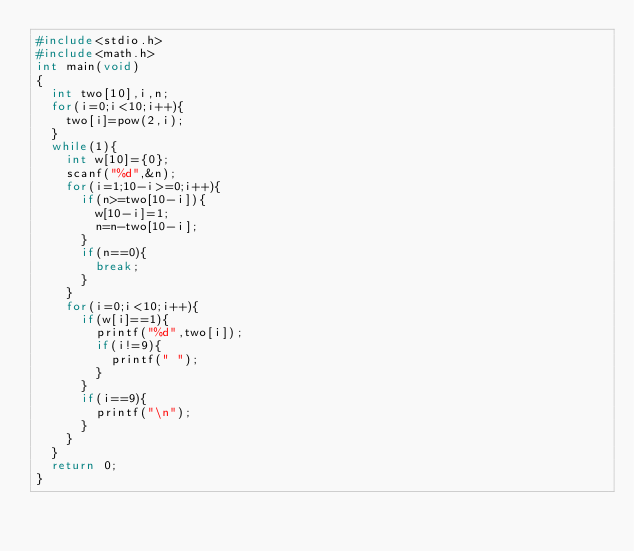<code> <loc_0><loc_0><loc_500><loc_500><_C_>#include<stdio.h>
#include<math.h>
int main(void)
{
	int two[10],i,n;
	for(i=0;i<10;i++){
		two[i]=pow(2,i);
	}
	while(1){
		int w[10]={0};
		scanf("%d",&n);
		for(i=1;10-i>=0;i++){
			if(n>=two[10-i]){
				w[10-i]=1;
				n=n-two[10-i];
			}
			if(n==0){
				break;
			}
		}
		for(i=0;i<10;i++){
			if(w[i]==1){
				printf("%d",two[i]);
				if(i!=9){
					printf(" ");
				}
			}
			if(i==9){
				printf("\n");
			}
		}
	}
	return 0;
}</code> 